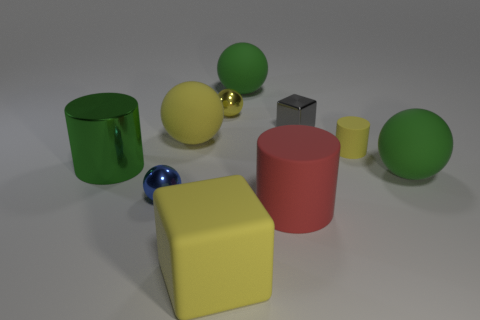Subtract all large green cylinders. How many cylinders are left? 2 Subtract 2 spheres. How many spheres are left? 3 Subtract all blue spheres. How many spheres are left? 4 Subtract all cylinders. How many objects are left? 7 Subtract all purple cylinders. How many green balls are left? 2 Add 8 small yellow rubber things. How many small yellow rubber things exist? 9 Subtract 0 red spheres. How many objects are left? 10 Subtract all brown cubes. Subtract all cyan cylinders. How many cubes are left? 2 Subtract all small blue metallic blocks. Subtract all large green rubber objects. How many objects are left? 8 Add 6 small blue metal objects. How many small blue metal objects are left? 7 